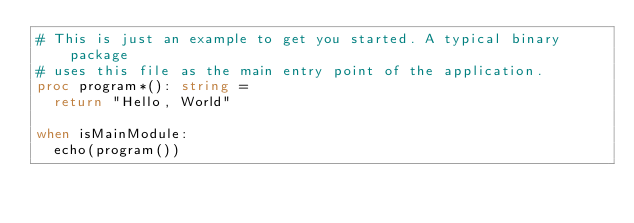Convert code to text. <code><loc_0><loc_0><loc_500><loc_500><_Nim_># This is just an example to get you started. A typical binary package
# uses this file as the main entry point of the application.
proc program*(): string =
  return "Hello, World"

when isMainModule:
  echo(program())
</code> 